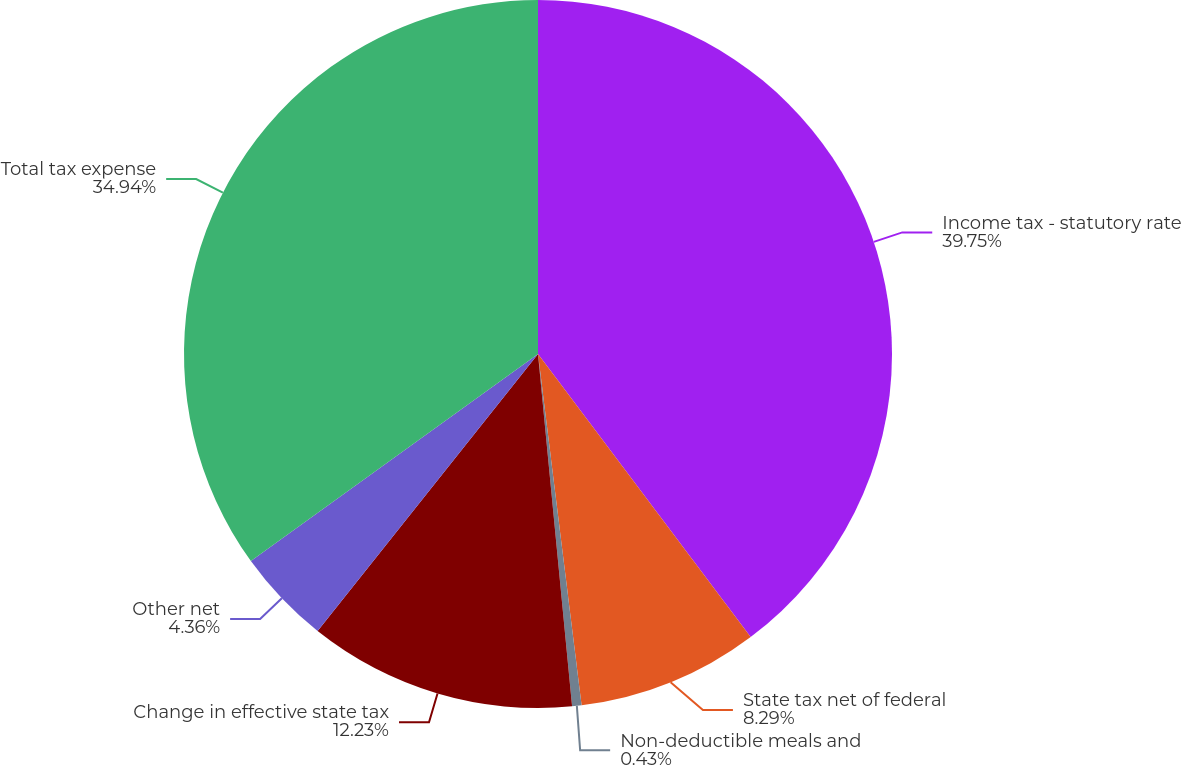Convert chart to OTSL. <chart><loc_0><loc_0><loc_500><loc_500><pie_chart><fcel>Income tax - statutory rate<fcel>State tax net of federal<fcel>Non-deductible meals and<fcel>Change in effective state tax<fcel>Other net<fcel>Total tax expense<nl><fcel>39.74%<fcel>8.29%<fcel>0.43%<fcel>12.23%<fcel>4.36%<fcel>34.94%<nl></chart> 